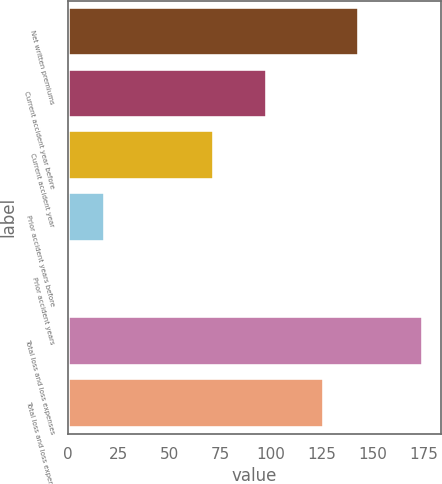Convert chart. <chart><loc_0><loc_0><loc_500><loc_500><bar_chart><fcel>Net written premiums<fcel>Current accident year before<fcel>Current accident year<fcel>Prior accident years before<fcel>Prior accident years<fcel>Total loss and loss expenses<fcel>Total loss and loss expense<nl><fcel>143.4<fcel>98<fcel>72<fcel>18.4<fcel>1<fcel>175<fcel>126<nl></chart> 